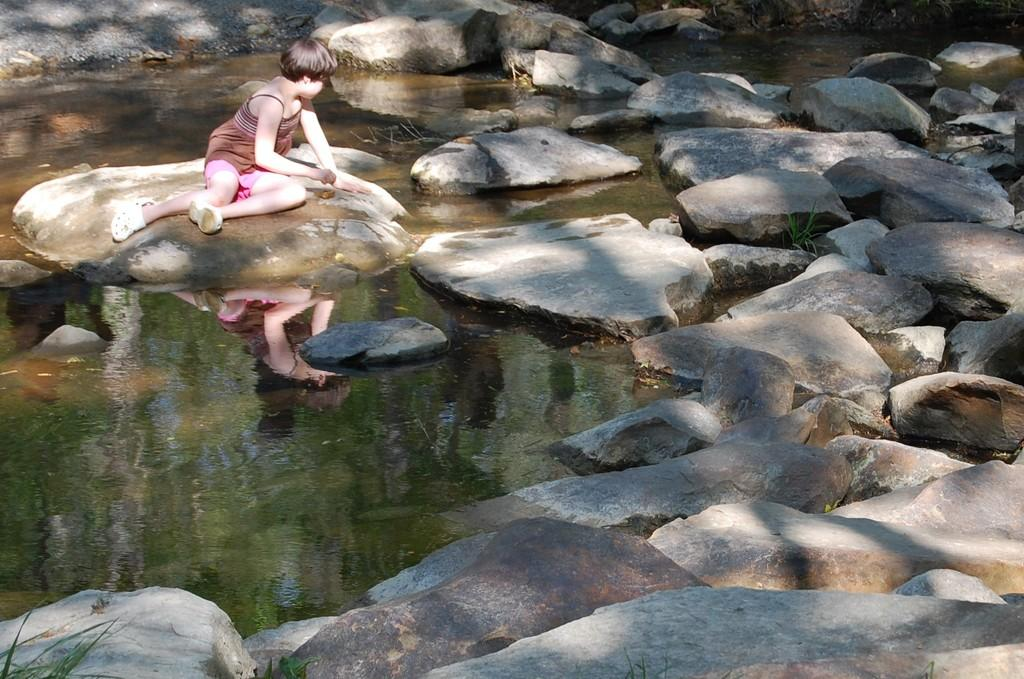What is the main subject of the picture? The main subject of the picture is a kid. Where is the kid sitting in the image? The kid is sitting on a rock. What can be seen on the right side of the kid? There are rocks on the right side of the kid. What is the water in the image doing? The water reflects the kid's image. What type of coal can be seen in the image? There is no coal present in the image. How many spoons are visible in the image? There is no spoon present in the image. 